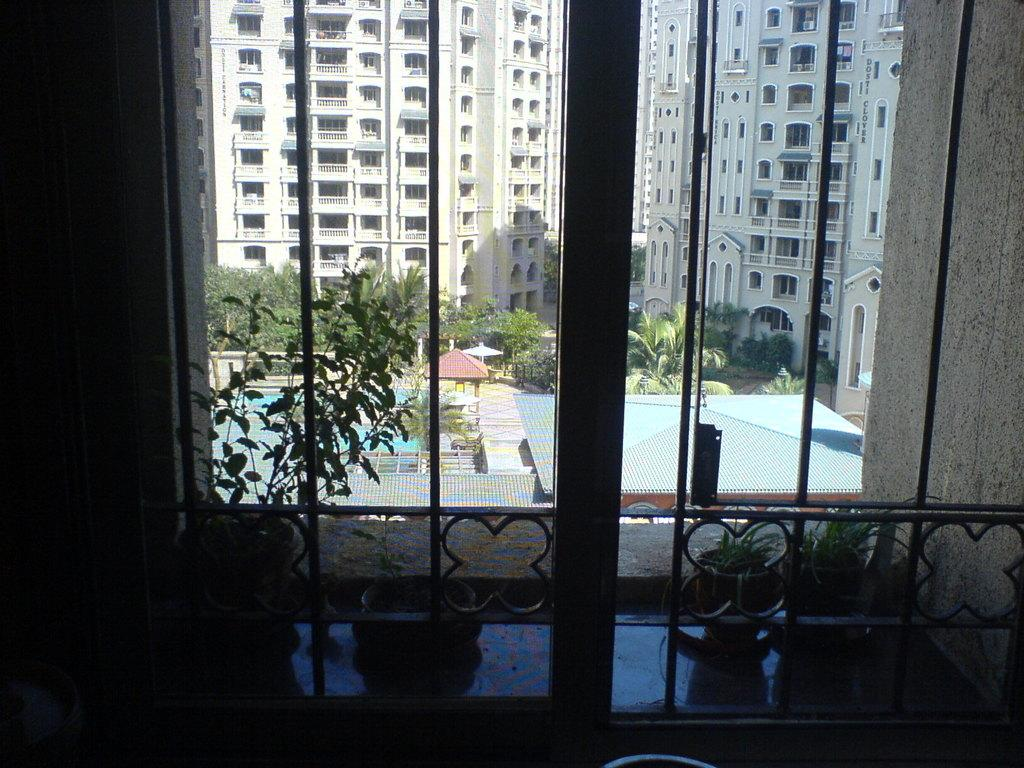What can be seen in the image that provides a view of the outdoors? There is a window in the image that allows for a view of the outdoors. What feature is present on the window? The window has a metal grill. What is the color of the metal grill? The metal grill is black in color. What can be seen through the window? Trees, a swimming pool, and buildings are visible through the window. Who is the representative of the window in the image? There is no representative of the window in the image, as it is an inanimate object. 